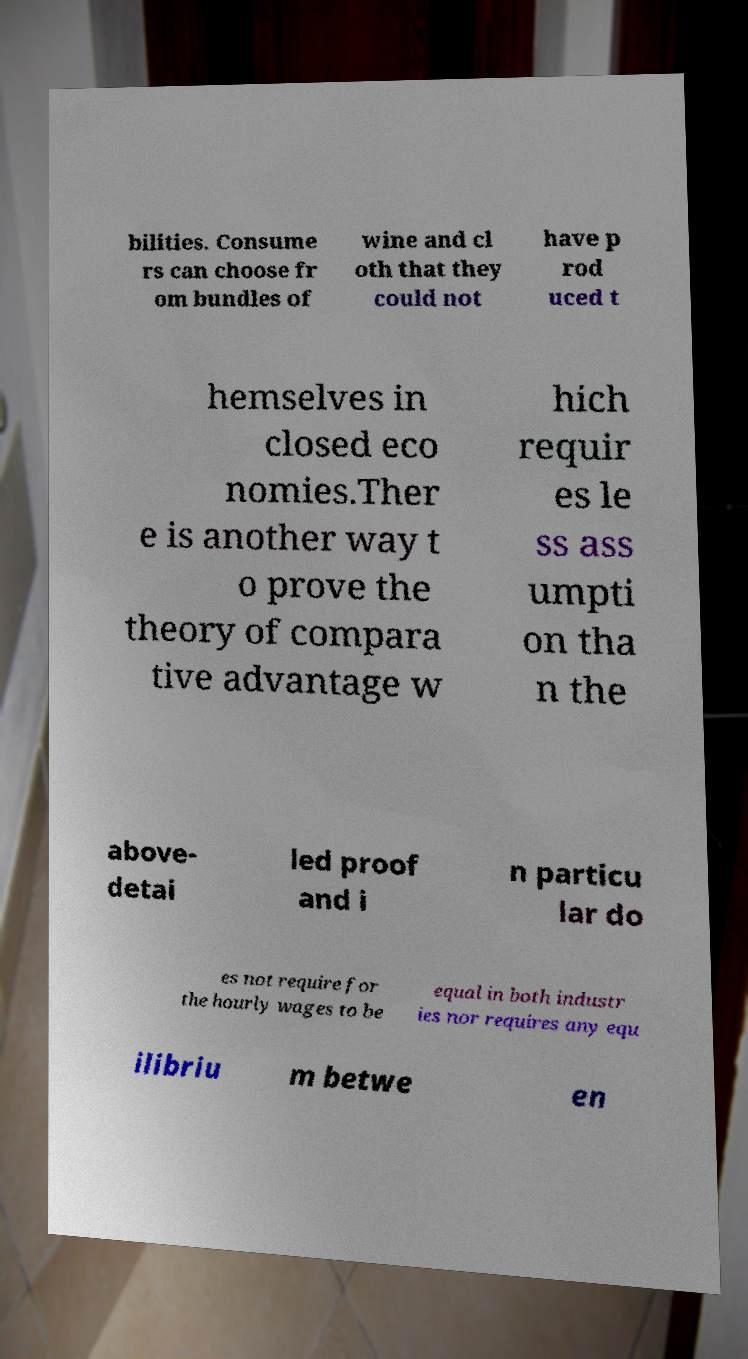For documentation purposes, I need the text within this image transcribed. Could you provide that? bilities. Consume rs can choose fr om bundles of wine and cl oth that they could not have p rod uced t hemselves in closed eco nomies.Ther e is another way t o prove the theory of compara tive advantage w hich requir es le ss ass umpti on tha n the above- detai led proof and i n particu lar do es not require for the hourly wages to be equal in both industr ies nor requires any equ ilibriu m betwe en 